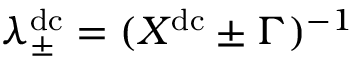<formula> <loc_0><loc_0><loc_500><loc_500>\lambda _ { \pm } ^ { d c } = ( X ^ { d c } \pm \Gamma ) ^ { - 1 }</formula> 